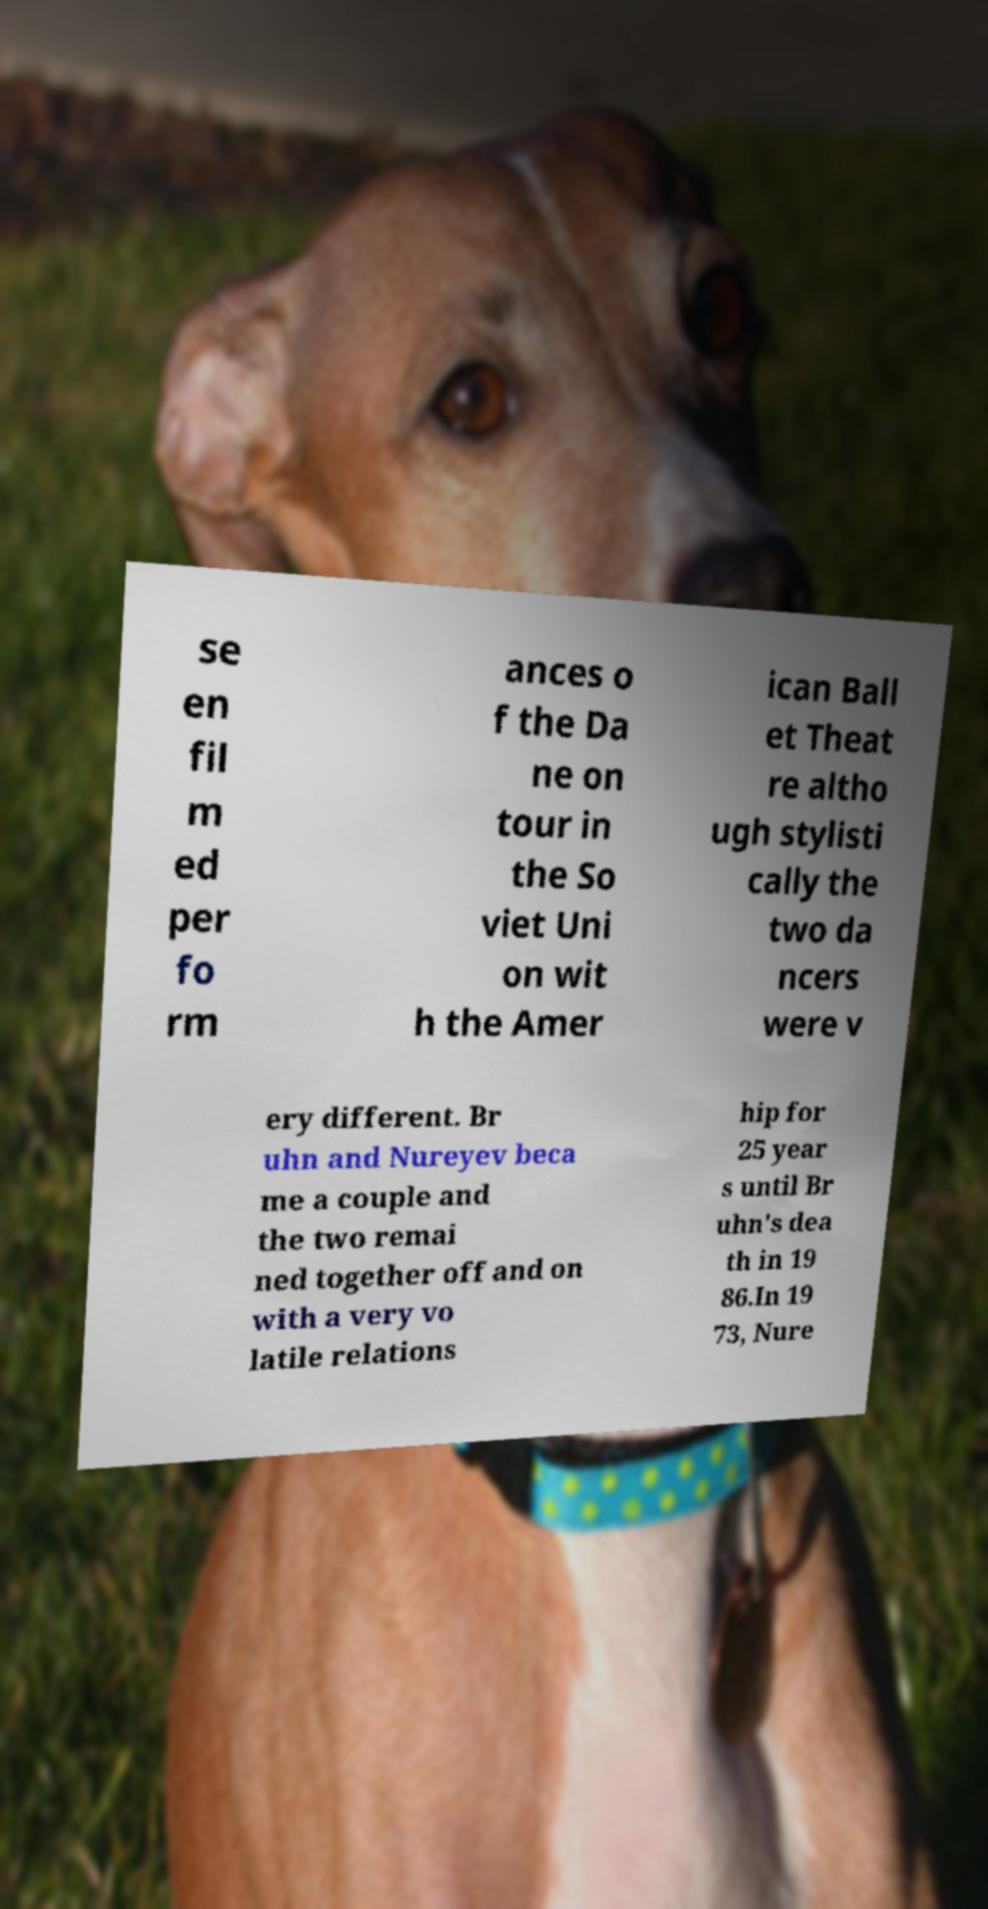I need the written content from this picture converted into text. Can you do that? se en fil m ed per fo rm ances o f the Da ne on tour in the So viet Uni on wit h the Amer ican Ball et Theat re altho ugh stylisti cally the two da ncers were v ery different. Br uhn and Nureyev beca me a couple and the two remai ned together off and on with a very vo latile relations hip for 25 year s until Br uhn's dea th in 19 86.In 19 73, Nure 